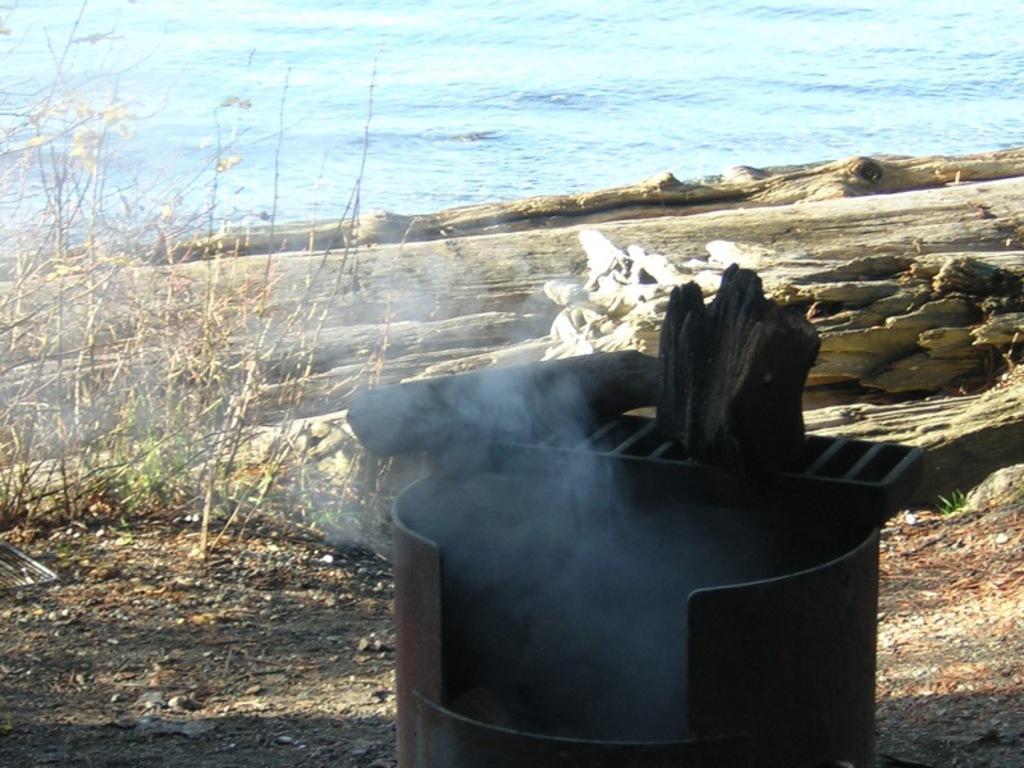Can you describe this image briefly? In this image in the front there is a drum and on the top of the drum there are wooden objects. In the center there are plants and there is a wooden log. In the background there is water. 